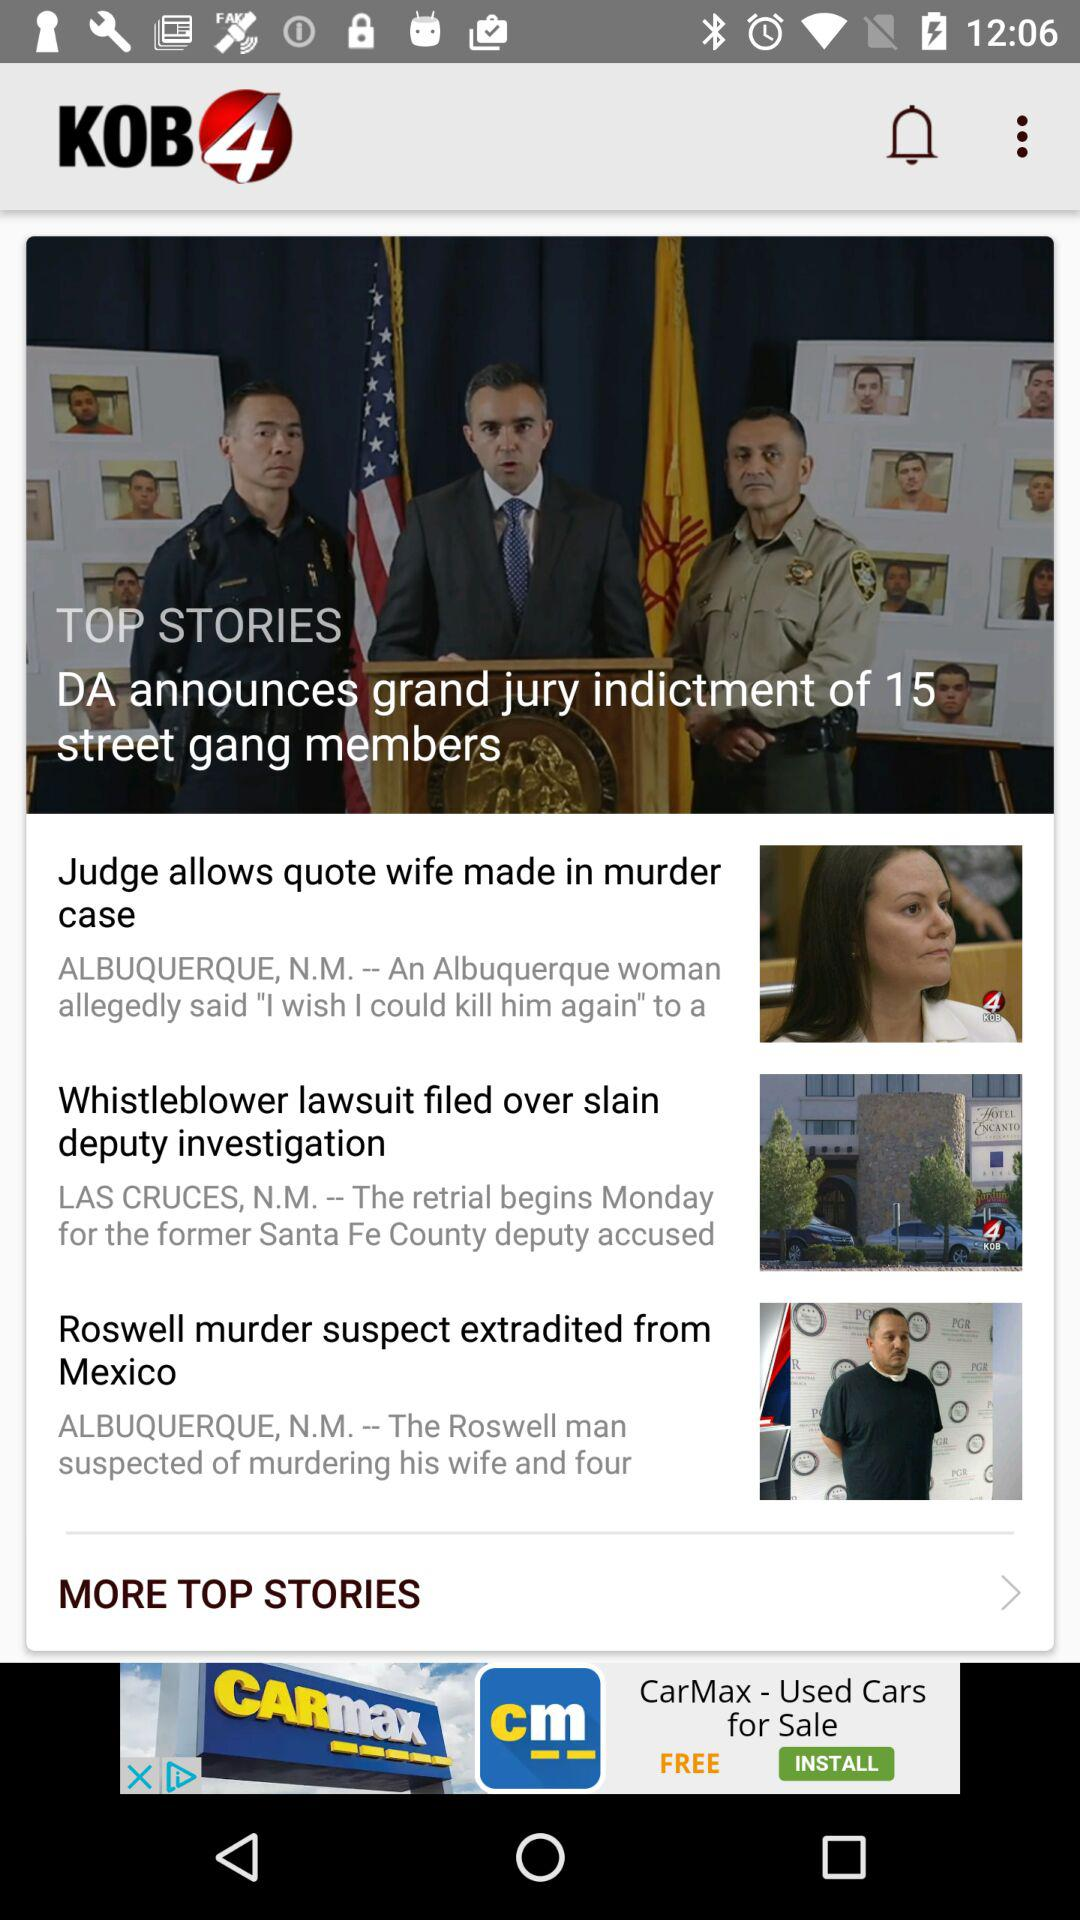What is the name of the application? The name of the application is "KOB4". 